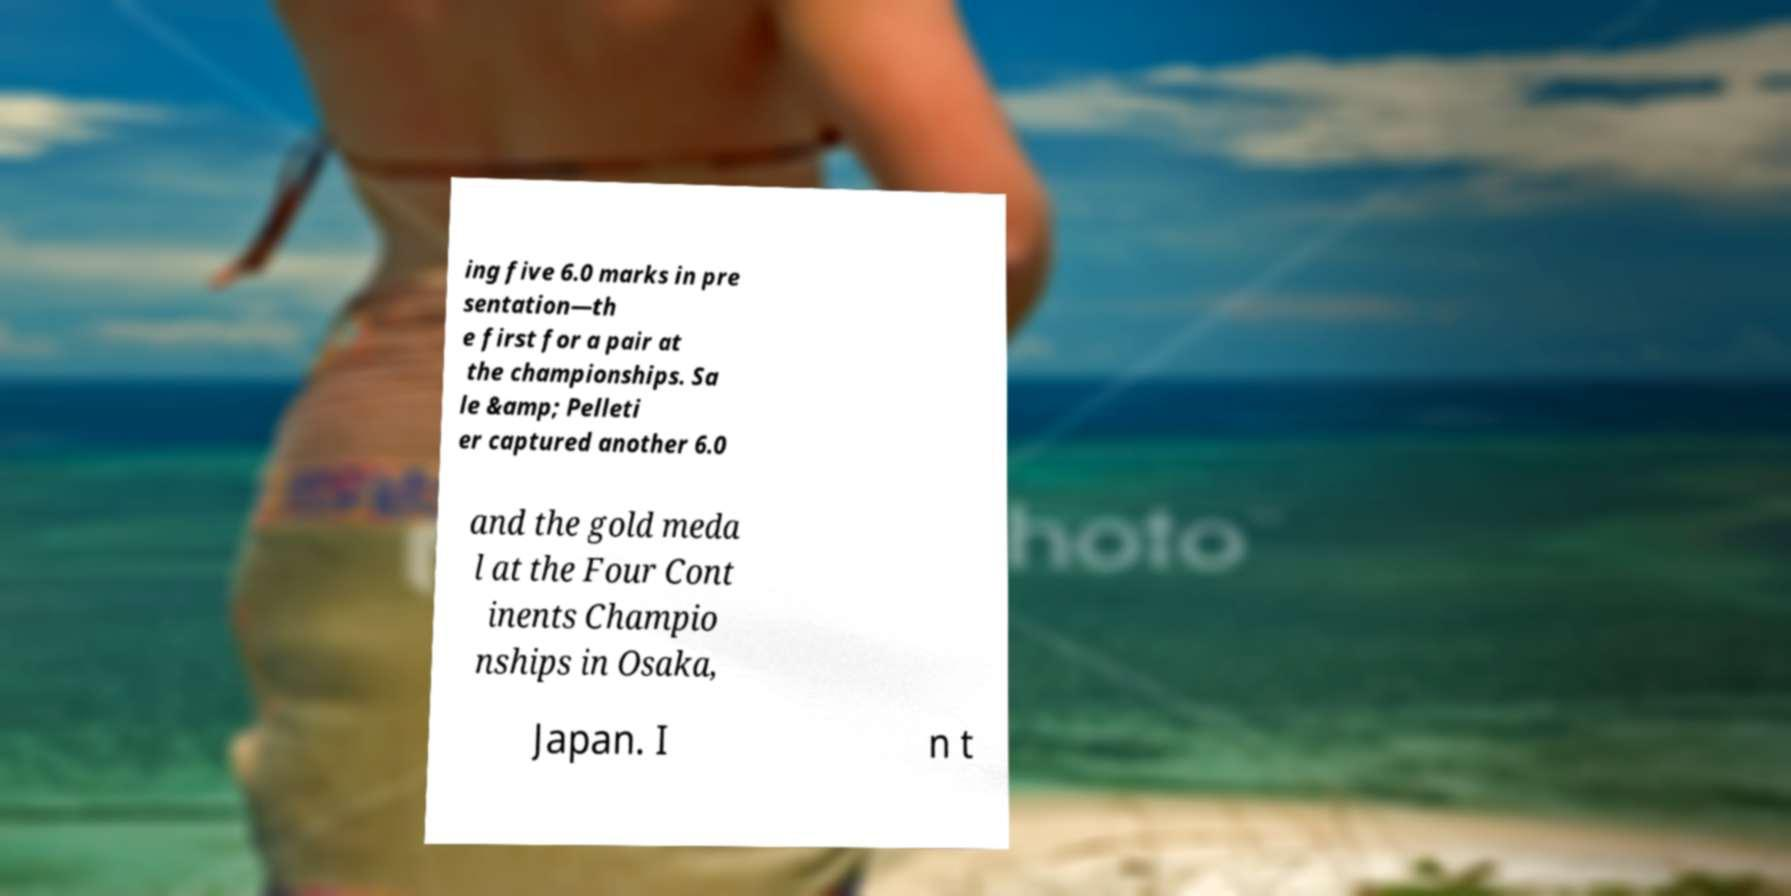I need the written content from this picture converted into text. Can you do that? ing five 6.0 marks in pre sentation—th e first for a pair at the championships. Sa le &amp; Pelleti er captured another 6.0 and the gold meda l at the Four Cont inents Champio nships in Osaka, Japan. I n t 